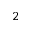Convert formula to latex. <formula><loc_0><loc_0><loc_500><loc_500>^ { 2 }</formula> 